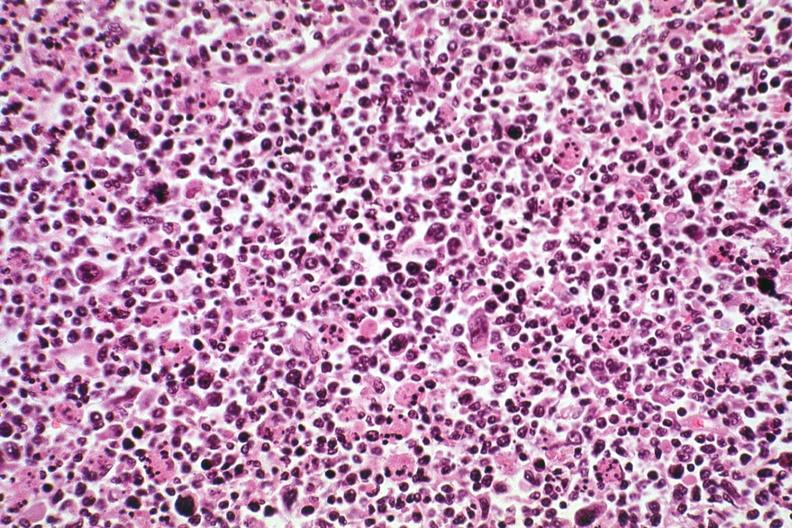what is present?
Answer the question using a single word or phrase. Lymph node 